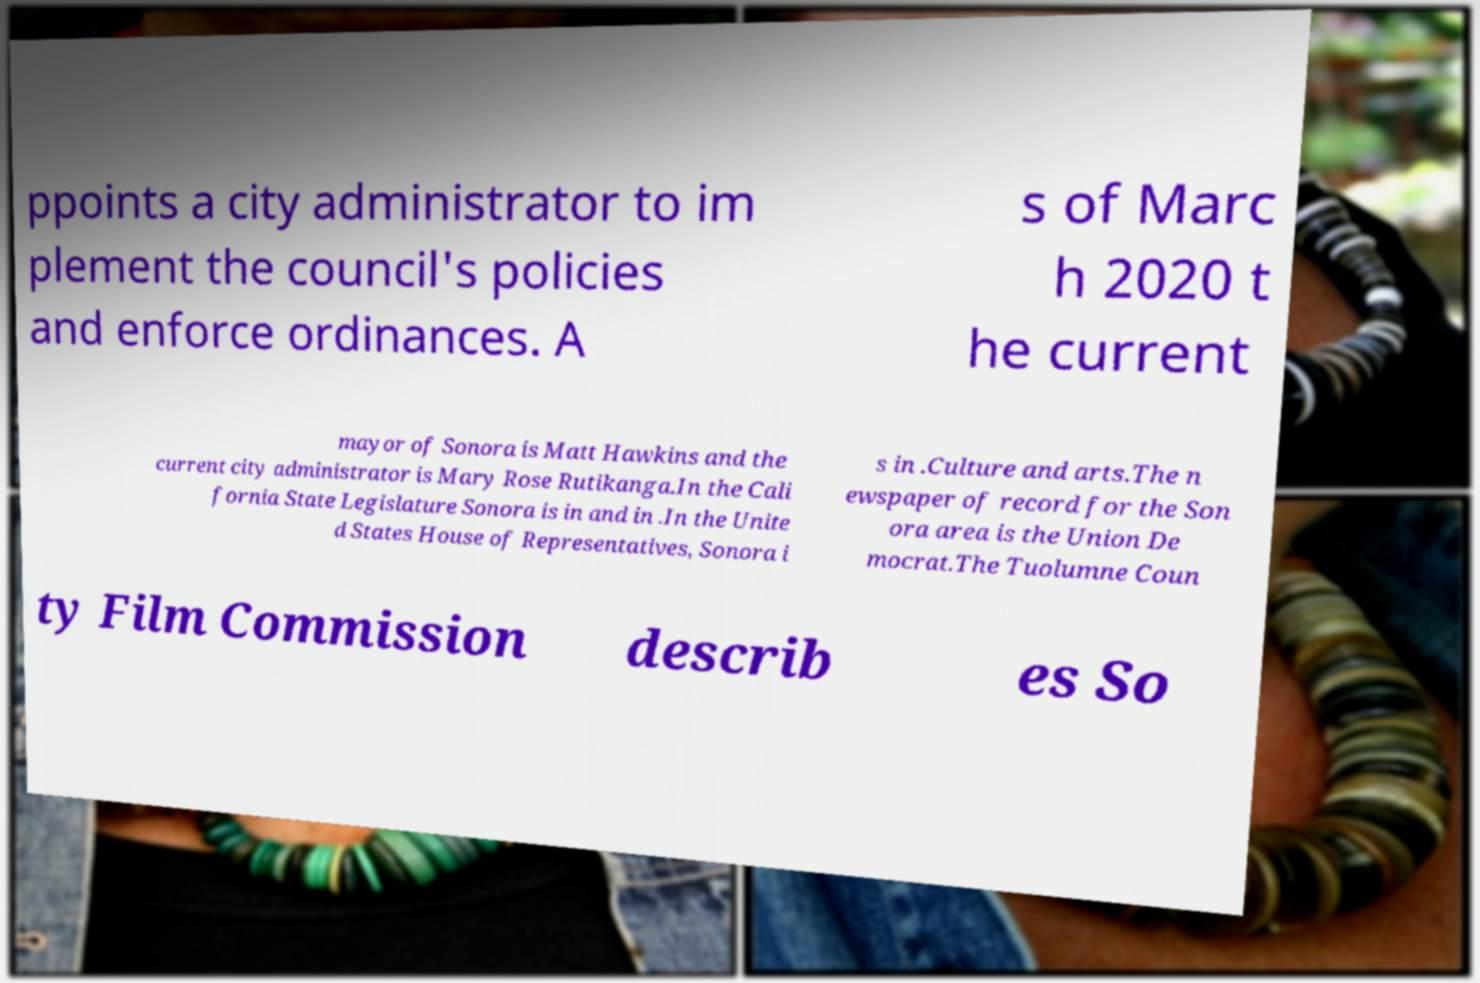Please identify and transcribe the text found in this image. ppoints a city administrator to im plement the council's policies and enforce ordinances. A s of Marc h 2020 t he current mayor of Sonora is Matt Hawkins and the current city administrator is Mary Rose Rutikanga.In the Cali fornia State Legislature Sonora is in and in .In the Unite d States House of Representatives, Sonora i s in .Culture and arts.The n ewspaper of record for the Son ora area is the Union De mocrat.The Tuolumne Coun ty Film Commission describ es So 